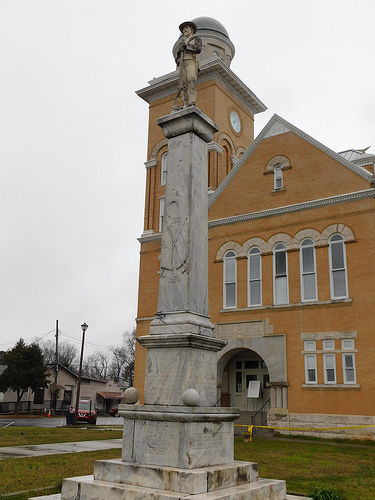<image>
Is there a statue behind the building? No. The statue is not behind the building. From this viewpoint, the statue appears to be positioned elsewhere in the scene. 